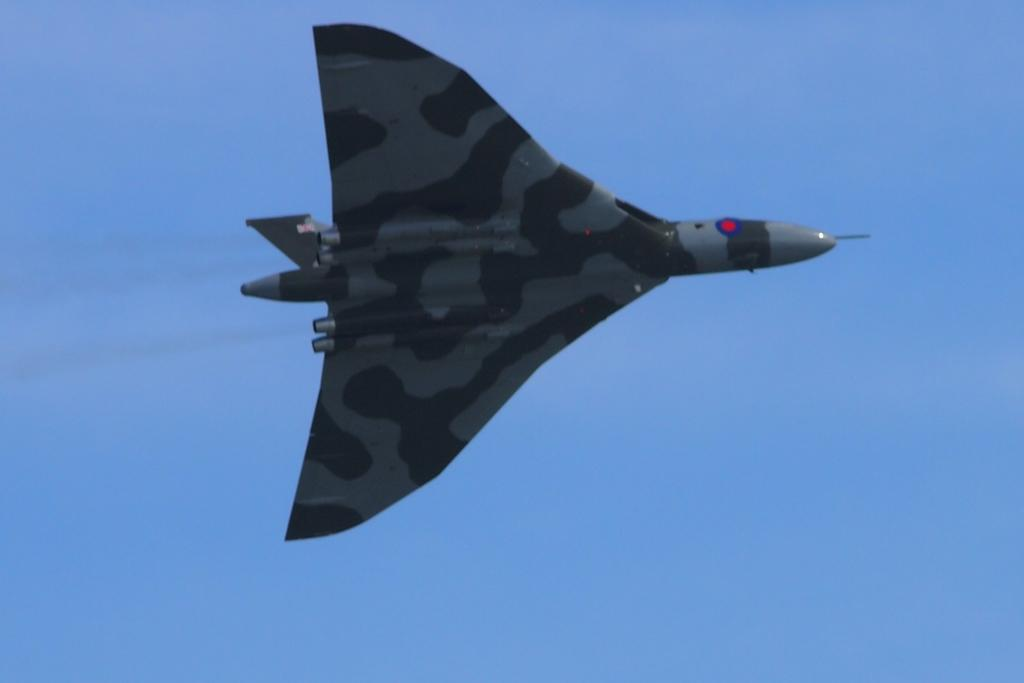What is the main subject of the picture? The main subject of the picture is an aircraft. What is the aircraft doing in the picture? The aircraft is flying. What can be seen in the background of the picture? The sky is visible behind the aircraft. What type of dinner is being served on the aircraft in the image? There is no dinner visible in the image, as it only features an aircraft flying in the sky. 